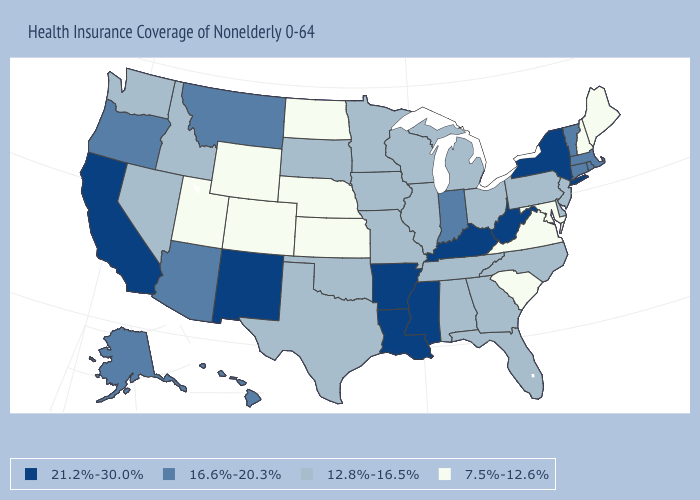What is the highest value in the USA?
Be succinct. 21.2%-30.0%. Does Colorado have a lower value than Illinois?
Write a very short answer. Yes. Name the states that have a value in the range 12.8%-16.5%?
Short answer required. Alabama, Delaware, Florida, Georgia, Idaho, Illinois, Iowa, Michigan, Minnesota, Missouri, Nevada, New Jersey, North Carolina, Ohio, Oklahoma, Pennsylvania, South Dakota, Tennessee, Texas, Washington, Wisconsin. Does Delaware have the same value as Oklahoma?
Short answer required. Yes. Name the states that have a value in the range 12.8%-16.5%?
Short answer required. Alabama, Delaware, Florida, Georgia, Idaho, Illinois, Iowa, Michigan, Minnesota, Missouri, Nevada, New Jersey, North Carolina, Ohio, Oklahoma, Pennsylvania, South Dakota, Tennessee, Texas, Washington, Wisconsin. Name the states that have a value in the range 21.2%-30.0%?
Short answer required. Arkansas, California, Kentucky, Louisiana, Mississippi, New Mexico, New York, West Virginia. Is the legend a continuous bar?
Keep it brief. No. Does the map have missing data?
Quick response, please. No. Name the states that have a value in the range 16.6%-20.3%?
Be succinct. Alaska, Arizona, Connecticut, Hawaii, Indiana, Massachusetts, Montana, Oregon, Rhode Island, Vermont. What is the value of Kentucky?
Short answer required. 21.2%-30.0%. Does Louisiana have a lower value than Virginia?
Keep it brief. No. How many symbols are there in the legend?
Be succinct. 4. Does Massachusetts have the highest value in the Northeast?
Keep it brief. No. Which states have the lowest value in the USA?
Keep it brief. Colorado, Kansas, Maine, Maryland, Nebraska, New Hampshire, North Dakota, South Carolina, Utah, Virginia, Wyoming. Among the states that border Delaware , does Maryland have the highest value?
Quick response, please. No. 